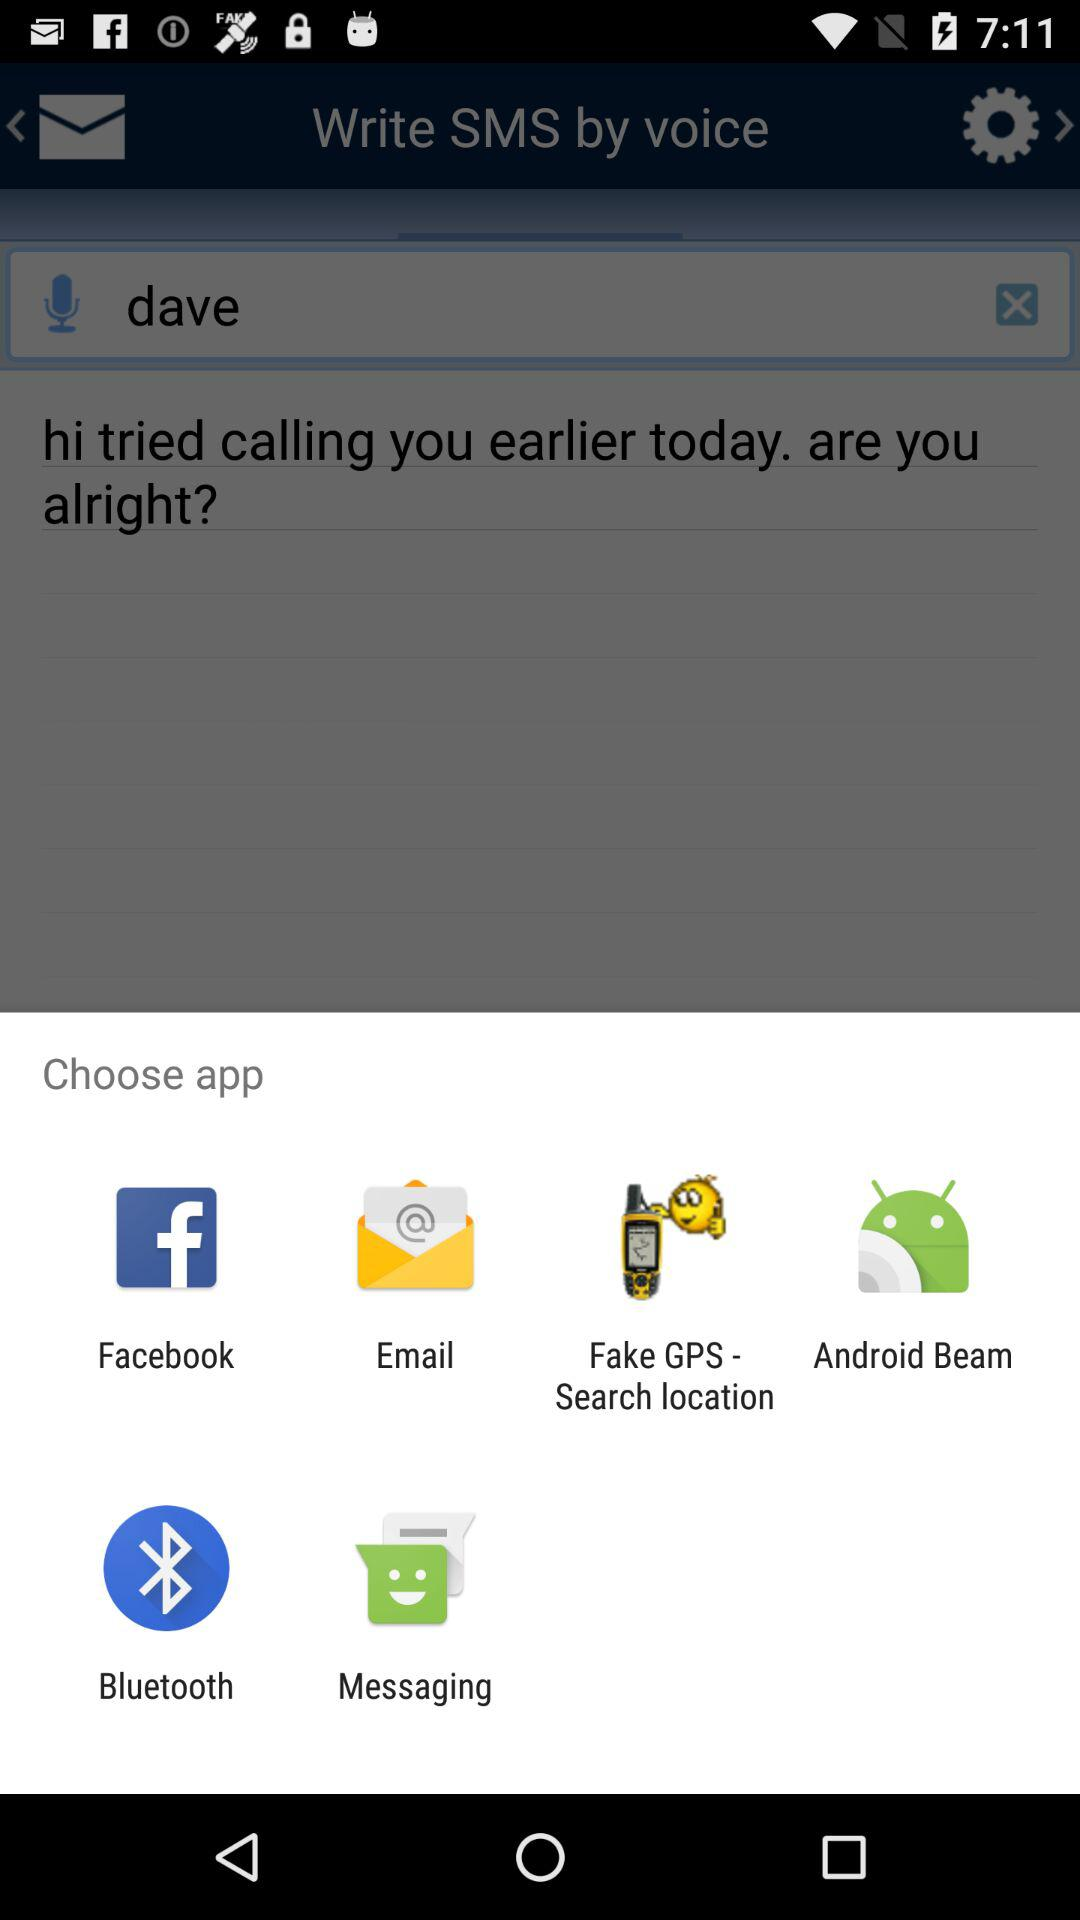Is there any application to search locations? The application is "Fake GPS - Search location". 